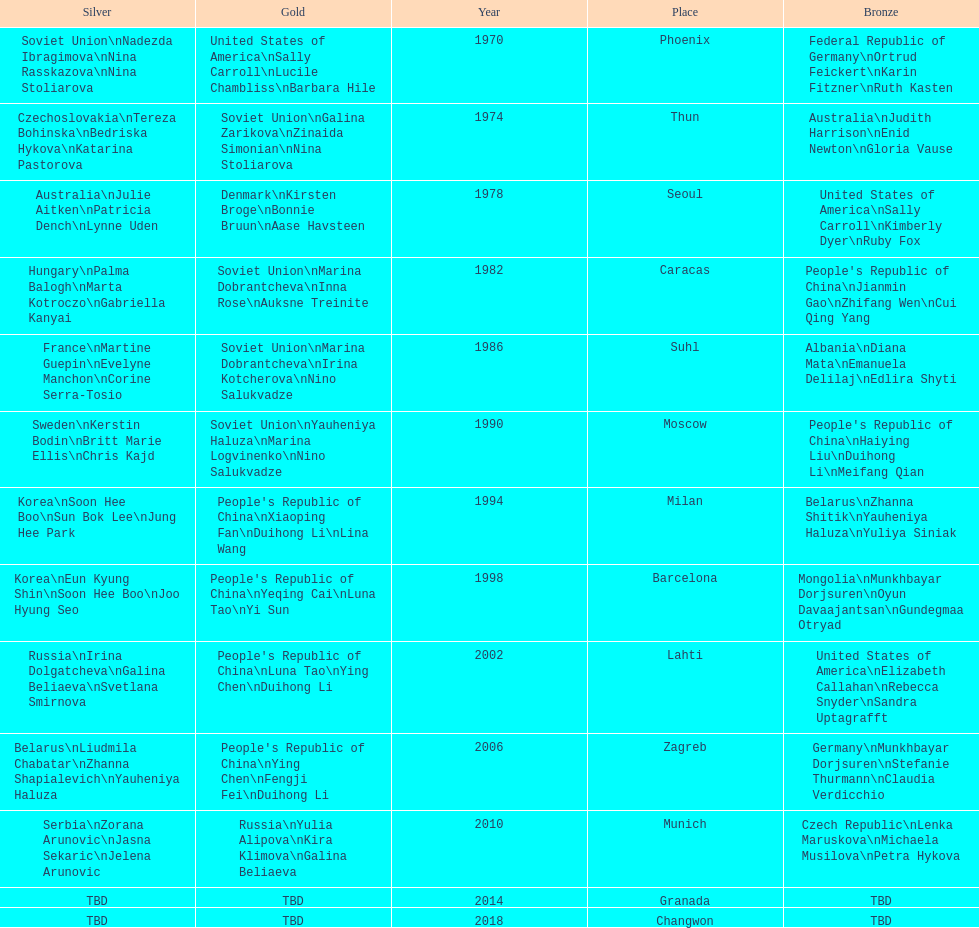In the women's 25-meter pistol world championship, how many times did the soviet union achieve victory? 4. 